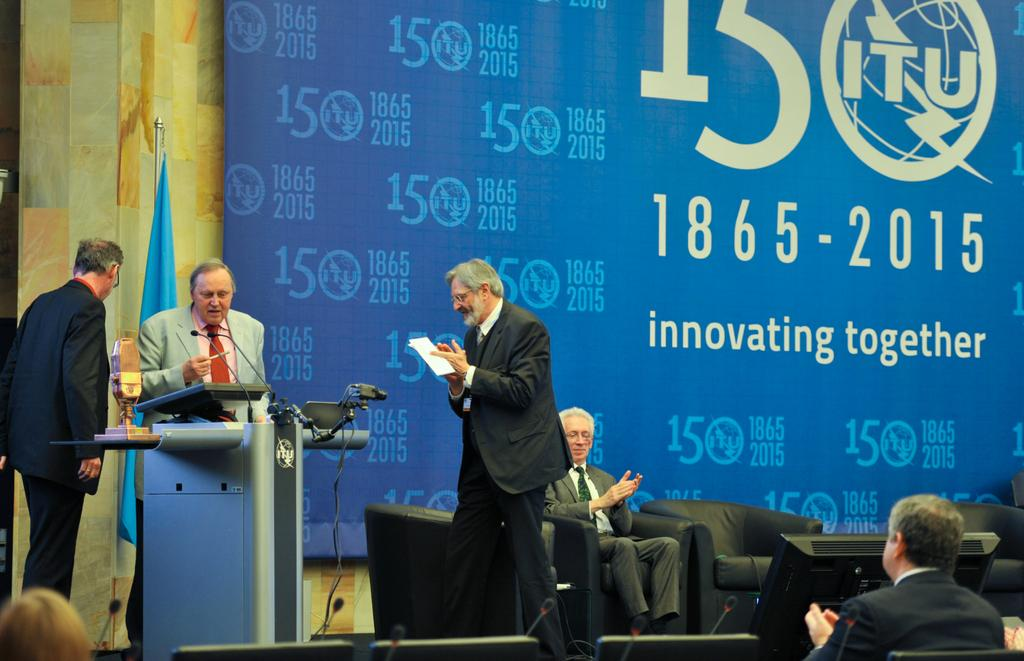Who is present in the image? There are people in the image, including a man. What is the man doing in the image? The man is standing in front of a desk. What can be seen in the foreground of the image? A mic is present in the foreground area of the image. What is visible in the background of the image? There is a poster and a flag in the background. What type of school is depicted in the image? There is no school present in the image. Can you tell me how many boots are visible in the image? There are no boots visible in the image. 